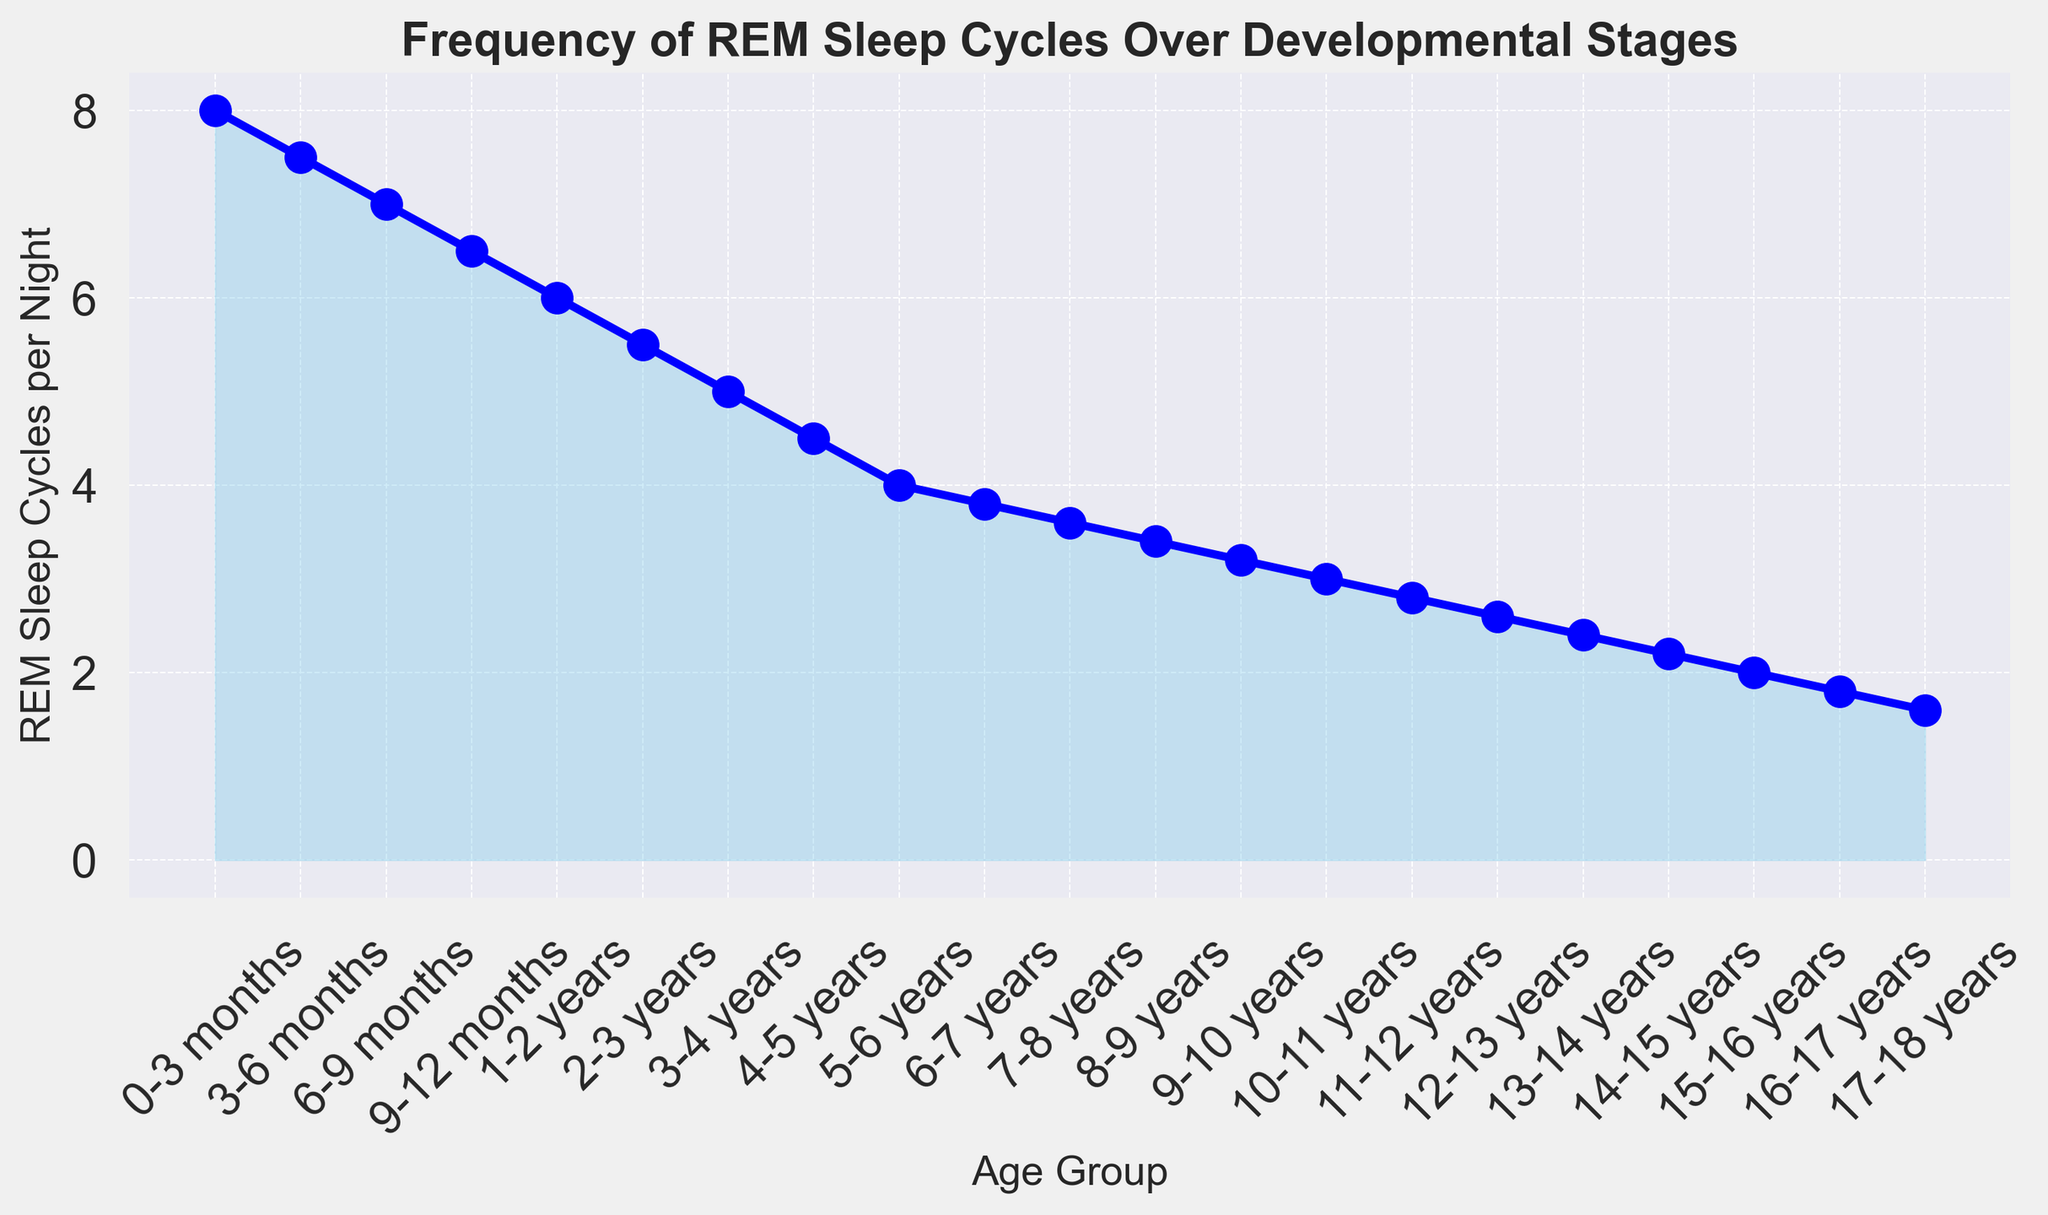What is the age group with the highest frequency of REM sleep cycles? The age group with the highest frequency of REM sleep cycles corresponds to the highest point on the y-axis of the figure. Looking at the graph, the 0-3 months age group has the highest number of REM sleep cycles per night.
Answer: 0-3 months How many REM sleep cycles per night are there for the 5-6 years age group, and is it higher or lower than the 1-2 years age group? First, locate the 5-6 years age group on the x-axis and check its corresponding y-axis value. It's 4 cycles per night. Then, find the 1-2 years age group, which is 6 cycles per night. Comparing the two, 4 is less than 6.
Answer: 4, lower What is the difference in the number of REM sleep cycles between the ages 3-6 months and 6-9 months? Identify the y-values for 3-6 months (7.5 cycles) and 6-9 months (7 cycles). Subtract the latter from the former: 7.5 - 7 = 0.5.
Answer: 0.5 How does the number of REM sleep cycles per night change from the 2-3 years age group to the 4-5 years age group? Check the y-values for the 2-3 years (5.5 cycles) and 4-5 years (4.5 cycles) age groups. Calculate the difference: 5.5 - 4.5 = 1, indicating a decrease of 1 cycle.
Answer: Decreases by 1 What age group shows a REM sleep cycle value closest to 3 cycles per night? Look through the y-axis values to locate the data point closest to 3. The 10-11 years age group has exactly 3 cycles per night.
Answer: 10-11 years By how much do the REM sleep cycles decrease on average per developmental stage from 0-3 months to 17-18 years? Calculate the initial value (8 cycles at 0-3 months) and the final value (1.6 cycles at 17-18 years). The difference is 8 - 1.6 = 6.4. There are 21 age groups, so the average decrease is 6.4 / 20 ≈ 0.32 cycles per stage.
Answer: 0.32 Which age group has the same frequency of REM sleep cycles as the 13-14 years age group? The 13-14 years age group has 2.4 cycles per night. Scan the chart for other age groups with the same value. The only group with 2.4 cycles per night is 13-14 years itself.
Answer: None What is the rate of decrease in REM sleep cycles between 12-13 years and 15-16 years? Find the y-values for these age groups: 2.6 cycles for 12-13 years and 2 cycles for 15-16 years. Calculate the difference: 2.6 - 2 = 0.6, and note the decrease spans three age groups (13-14 years, 14-15 years, 15-16 years). The rate of decrease per group is 0.6 / 3 = 0.2 cycles per group.
Answer: 0.2 cycles per group What can you infer about the trend in REM sleep cycles as a child develops into a teenager? Observe the overall shape and direction of the chart. There is a clear decreasing trend in the frequency of REM sleep cycles from infancy through the teenage years.
Answer: Decreases consistently 